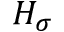<formula> <loc_0><loc_0><loc_500><loc_500>H _ { \sigma }</formula> 